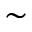Convert formula to latex. <formula><loc_0><loc_0><loc_500><loc_500>\sim</formula> 